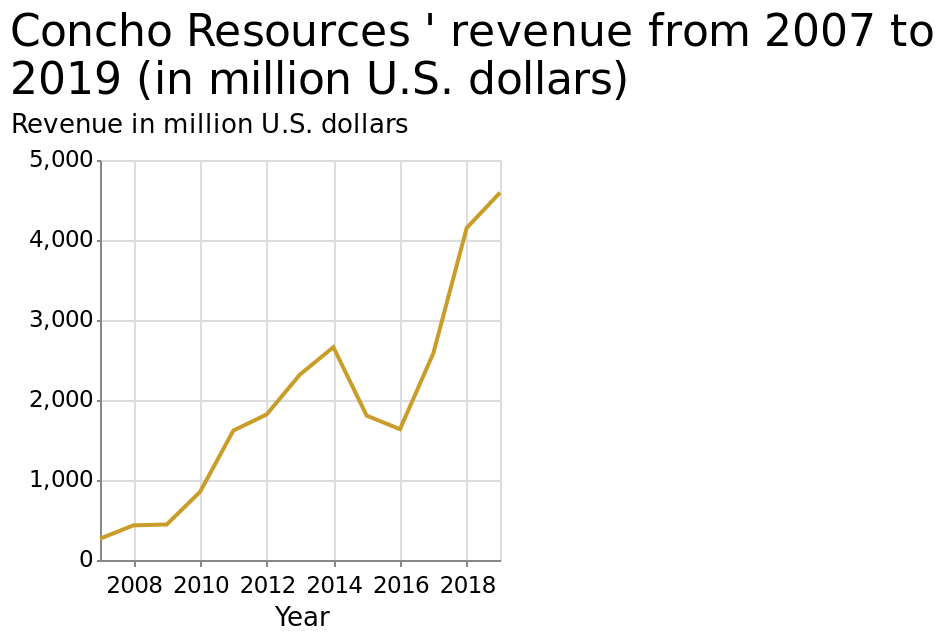<image>
Has there been any significant change in revenue growth trends recently? Revenue is generally increasing at a drastic rate over the years. Can you provide an overview of the revenue growth trend in recent years?  Revenue is generally increasing at a drastic rate over the years. 